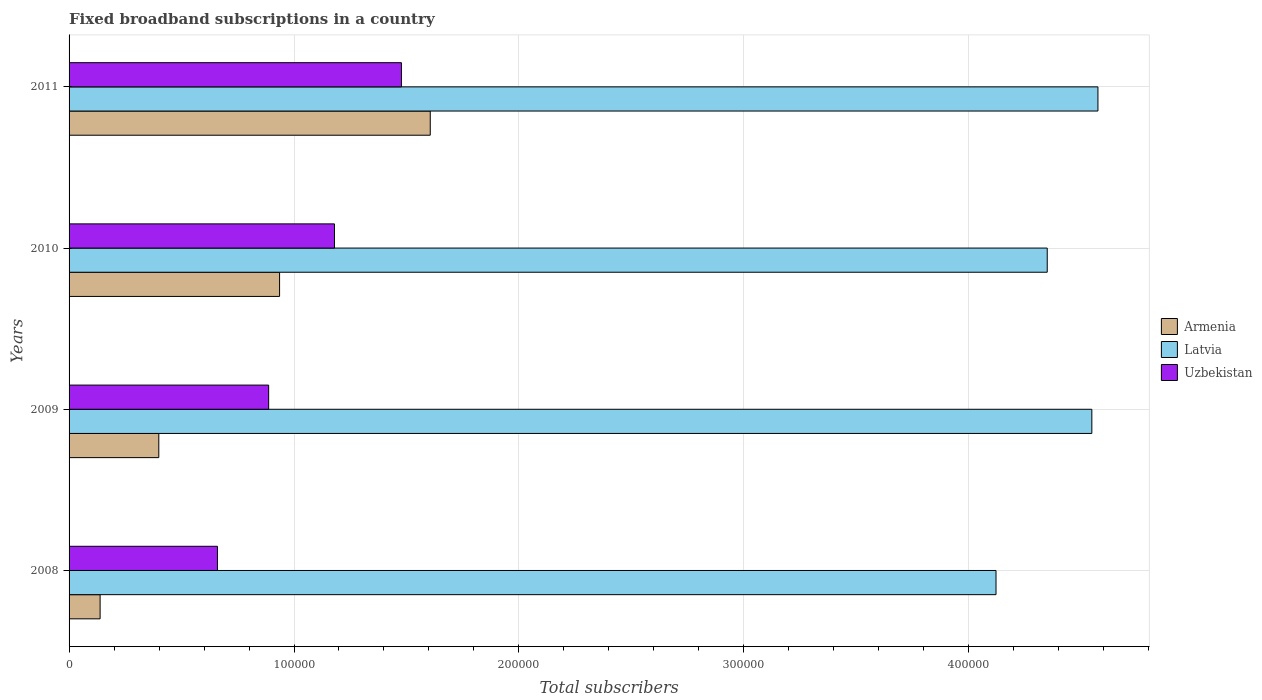Are the number of bars on each tick of the Y-axis equal?
Your answer should be compact. Yes. How many bars are there on the 2nd tick from the top?
Make the answer very short. 3. How many bars are there on the 1st tick from the bottom?
Offer a terse response. 3. In how many cases, is the number of bars for a given year not equal to the number of legend labels?
Your answer should be very brief. 0. What is the number of broadband subscriptions in Latvia in 2010?
Provide a short and direct response. 4.35e+05. Across all years, what is the maximum number of broadband subscriptions in Uzbekistan?
Offer a very short reply. 1.48e+05. Across all years, what is the minimum number of broadband subscriptions in Uzbekistan?
Provide a succinct answer. 6.60e+04. In which year was the number of broadband subscriptions in Latvia maximum?
Ensure brevity in your answer.  2011. What is the total number of broadband subscriptions in Armenia in the graph?
Your response must be concise. 3.08e+05. What is the difference between the number of broadband subscriptions in Latvia in 2009 and that in 2010?
Make the answer very short. 1.98e+04. What is the difference between the number of broadband subscriptions in Latvia in 2010 and the number of broadband subscriptions in Uzbekistan in 2008?
Ensure brevity in your answer.  3.69e+05. What is the average number of broadband subscriptions in Latvia per year?
Your answer should be very brief. 4.40e+05. In the year 2009, what is the difference between the number of broadband subscriptions in Latvia and number of broadband subscriptions in Armenia?
Give a very brief answer. 4.15e+05. In how many years, is the number of broadband subscriptions in Armenia greater than 460000 ?
Offer a very short reply. 0. What is the ratio of the number of broadband subscriptions in Uzbekistan in 2009 to that in 2011?
Keep it short and to the point. 0.6. Is the difference between the number of broadband subscriptions in Latvia in 2009 and 2011 greater than the difference between the number of broadband subscriptions in Armenia in 2009 and 2011?
Keep it short and to the point. Yes. What is the difference between the highest and the second highest number of broadband subscriptions in Armenia?
Your answer should be compact. 6.70e+04. What is the difference between the highest and the lowest number of broadband subscriptions in Armenia?
Offer a terse response. 1.47e+05. In how many years, is the number of broadband subscriptions in Latvia greater than the average number of broadband subscriptions in Latvia taken over all years?
Provide a short and direct response. 2. Is the sum of the number of broadband subscriptions in Armenia in 2008 and 2009 greater than the maximum number of broadband subscriptions in Uzbekistan across all years?
Provide a succinct answer. No. What does the 3rd bar from the top in 2011 represents?
Ensure brevity in your answer.  Armenia. What does the 3rd bar from the bottom in 2010 represents?
Your answer should be compact. Uzbekistan. Are all the bars in the graph horizontal?
Your answer should be very brief. Yes. How many years are there in the graph?
Provide a succinct answer. 4. What is the title of the graph?
Keep it short and to the point. Fixed broadband subscriptions in a country. What is the label or title of the X-axis?
Your answer should be very brief. Total subscribers. What is the Total subscribers of Armenia in 2008?
Make the answer very short. 1.38e+04. What is the Total subscribers of Latvia in 2008?
Your answer should be compact. 4.12e+05. What is the Total subscribers of Uzbekistan in 2008?
Offer a very short reply. 6.60e+04. What is the Total subscribers of Armenia in 2009?
Provide a succinct answer. 3.99e+04. What is the Total subscribers in Latvia in 2009?
Provide a short and direct response. 4.55e+05. What is the Total subscribers in Uzbekistan in 2009?
Your response must be concise. 8.87e+04. What is the Total subscribers in Armenia in 2010?
Ensure brevity in your answer.  9.36e+04. What is the Total subscribers of Latvia in 2010?
Give a very brief answer. 4.35e+05. What is the Total subscribers of Uzbekistan in 2010?
Your response must be concise. 1.18e+05. What is the Total subscribers in Armenia in 2011?
Ensure brevity in your answer.  1.61e+05. What is the Total subscribers in Latvia in 2011?
Offer a very short reply. 4.57e+05. What is the Total subscribers of Uzbekistan in 2011?
Ensure brevity in your answer.  1.48e+05. Across all years, what is the maximum Total subscribers of Armenia?
Ensure brevity in your answer.  1.61e+05. Across all years, what is the maximum Total subscribers of Latvia?
Provide a short and direct response. 4.57e+05. Across all years, what is the maximum Total subscribers of Uzbekistan?
Your answer should be compact. 1.48e+05. Across all years, what is the minimum Total subscribers of Armenia?
Ensure brevity in your answer.  1.38e+04. Across all years, what is the minimum Total subscribers of Latvia?
Your response must be concise. 4.12e+05. Across all years, what is the minimum Total subscribers in Uzbekistan?
Keep it short and to the point. 6.60e+04. What is the total Total subscribers in Armenia in the graph?
Give a very brief answer. 3.08e+05. What is the total Total subscribers in Latvia in the graph?
Your answer should be compact. 1.76e+06. What is the total Total subscribers in Uzbekistan in the graph?
Give a very brief answer. 4.20e+05. What is the difference between the Total subscribers in Armenia in 2008 and that in 2009?
Offer a very short reply. -2.61e+04. What is the difference between the Total subscribers in Latvia in 2008 and that in 2009?
Provide a succinct answer. -4.26e+04. What is the difference between the Total subscribers in Uzbekistan in 2008 and that in 2009?
Keep it short and to the point. -2.28e+04. What is the difference between the Total subscribers in Armenia in 2008 and that in 2010?
Offer a very short reply. -7.98e+04. What is the difference between the Total subscribers in Latvia in 2008 and that in 2010?
Offer a terse response. -2.28e+04. What is the difference between the Total subscribers in Uzbekistan in 2008 and that in 2010?
Ensure brevity in your answer.  -5.20e+04. What is the difference between the Total subscribers of Armenia in 2008 and that in 2011?
Give a very brief answer. -1.47e+05. What is the difference between the Total subscribers of Latvia in 2008 and that in 2011?
Your answer should be compact. -4.53e+04. What is the difference between the Total subscribers of Uzbekistan in 2008 and that in 2011?
Your response must be concise. -8.18e+04. What is the difference between the Total subscribers of Armenia in 2009 and that in 2010?
Offer a terse response. -5.37e+04. What is the difference between the Total subscribers in Latvia in 2009 and that in 2010?
Offer a terse response. 1.98e+04. What is the difference between the Total subscribers in Uzbekistan in 2009 and that in 2010?
Offer a very short reply. -2.93e+04. What is the difference between the Total subscribers in Armenia in 2009 and that in 2011?
Provide a succinct answer. -1.21e+05. What is the difference between the Total subscribers in Latvia in 2009 and that in 2011?
Offer a very short reply. -2708. What is the difference between the Total subscribers of Uzbekistan in 2009 and that in 2011?
Your answer should be compact. -5.90e+04. What is the difference between the Total subscribers in Armenia in 2010 and that in 2011?
Your answer should be very brief. -6.70e+04. What is the difference between the Total subscribers of Latvia in 2010 and that in 2011?
Keep it short and to the point. -2.25e+04. What is the difference between the Total subscribers in Uzbekistan in 2010 and that in 2011?
Offer a very short reply. -2.98e+04. What is the difference between the Total subscribers in Armenia in 2008 and the Total subscribers in Latvia in 2009?
Your response must be concise. -4.41e+05. What is the difference between the Total subscribers of Armenia in 2008 and the Total subscribers of Uzbekistan in 2009?
Offer a terse response. -7.49e+04. What is the difference between the Total subscribers of Latvia in 2008 and the Total subscribers of Uzbekistan in 2009?
Offer a terse response. 3.23e+05. What is the difference between the Total subscribers of Armenia in 2008 and the Total subscribers of Latvia in 2010?
Ensure brevity in your answer.  -4.21e+05. What is the difference between the Total subscribers of Armenia in 2008 and the Total subscribers of Uzbekistan in 2010?
Your response must be concise. -1.04e+05. What is the difference between the Total subscribers of Latvia in 2008 and the Total subscribers of Uzbekistan in 2010?
Provide a short and direct response. 2.94e+05. What is the difference between the Total subscribers of Armenia in 2008 and the Total subscribers of Latvia in 2011?
Offer a terse response. -4.44e+05. What is the difference between the Total subscribers in Armenia in 2008 and the Total subscribers in Uzbekistan in 2011?
Your response must be concise. -1.34e+05. What is the difference between the Total subscribers in Latvia in 2008 and the Total subscribers in Uzbekistan in 2011?
Your answer should be compact. 2.64e+05. What is the difference between the Total subscribers of Armenia in 2009 and the Total subscribers of Latvia in 2010?
Provide a short and direct response. -3.95e+05. What is the difference between the Total subscribers in Armenia in 2009 and the Total subscribers in Uzbekistan in 2010?
Give a very brief answer. -7.81e+04. What is the difference between the Total subscribers in Latvia in 2009 and the Total subscribers in Uzbekistan in 2010?
Offer a very short reply. 3.37e+05. What is the difference between the Total subscribers in Armenia in 2009 and the Total subscribers in Latvia in 2011?
Offer a very short reply. -4.18e+05. What is the difference between the Total subscribers in Armenia in 2009 and the Total subscribers in Uzbekistan in 2011?
Offer a terse response. -1.08e+05. What is the difference between the Total subscribers in Latvia in 2009 and the Total subscribers in Uzbekistan in 2011?
Provide a short and direct response. 3.07e+05. What is the difference between the Total subscribers in Armenia in 2010 and the Total subscribers in Latvia in 2011?
Make the answer very short. -3.64e+05. What is the difference between the Total subscribers of Armenia in 2010 and the Total subscribers of Uzbekistan in 2011?
Make the answer very short. -5.42e+04. What is the difference between the Total subscribers of Latvia in 2010 and the Total subscribers of Uzbekistan in 2011?
Keep it short and to the point. 2.87e+05. What is the average Total subscribers of Armenia per year?
Provide a short and direct response. 7.70e+04. What is the average Total subscribers in Latvia per year?
Keep it short and to the point. 4.40e+05. What is the average Total subscribers in Uzbekistan per year?
Give a very brief answer. 1.05e+05. In the year 2008, what is the difference between the Total subscribers in Armenia and Total subscribers in Latvia?
Your response must be concise. -3.98e+05. In the year 2008, what is the difference between the Total subscribers of Armenia and Total subscribers of Uzbekistan?
Offer a terse response. -5.22e+04. In the year 2008, what is the difference between the Total subscribers in Latvia and Total subscribers in Uzbekistan?
Your answer should be compact. 3.46e+05. In the year 2009, what is the difference between the Total subscribers of Armenia and Total subscribers of Latvia?
Your response must be concise. -4.15e+05. In the year 2009, what is the difference between the Total subscribers of Armenia and Total subscribers of Uzbekistan?
Offer a terse response. -4.88e+04. In the year 2009, what is the difference between the Total subscribers in Latvia and Total subscribers in Uzbekistan?
Offer a very short reply. 3.66e+05. In the year 2010, what is the difference between the Total subscribers of Armenia and Total subscribers of Latvia?
Offer a very short reply. -3.41e+05. In the year 2010, what is the difference between the Total subscribers in Armenia and Total subscribers in Uzbekistan?
Your response must be concise. -2.44e+04. In the year 2010, what is the difference between the Total subscribers in Latvia and Total subscribers in Uzbekistan?
Provide a succinct answer. 3.17e+05. In the year 2011, what is the difference between the Total subscribers of Armenia and Total subscribers of Latvia?
Your answer should be very brief. -2.97e+05. In the year 2011, what is the difference between the Total subscribers of Armenia and Total subscribers of Uzbekistan?
Your response must be concise. 1.28e+04. In the year 2011, what is the difference between the Total subscribers of Latvia and Total subscribers of Uzbekistan?
Offer a terse response. 3.10e+05. What is the ratio of the Total subscribers in Armenia in 2008 to that in 2009?
Keep it short and to the point. 0.35. What is the ratio of the Total subscribers of Latvia in 2008 to that in 2009?
Your answer should be compact. 0.91. What is the ratio of the Total subscribers of Uzbekistan in 2008 to that in 2009?
Ensure brevity in your answer.  0.74. What is the ratio of the Total subscribers in Armenia in 2008 to that in 2010?
Ensure brevity in your answer.  0.15. What is the ratio of the Total subscribers in Latvia in 2008 to that in 2010?
Offer a terse response. 0.95. What is the ratio of the Total subscribers of Uzbekistan in 2008 to that in 2010?
Your answer should be very brief. 0.56. What is the ratio of the Total subscribers of Armenia in 2008 to that in 2011?
Offer a terse response. 0.09. What is the ratio of the Total subscribers of Latvia in 2008 to that in 2011?
Give a very brief answer. 0.9. What is the ratio of the Total subscribers in Uzbekistan in 2008 to that in 2011?
Provide a short and direct response. 0.45. What is the ratio of the Total subscribers of Armenia in 2009 to that in 2010?
Offer a terse response. 0.43. What is the ratio of the Total subscribers in Latvia in 2009 to that in 2010?
Your response must be concise. 1.05. What is the ratio of the Total subscribers in Uzbekistan in 2009 to that in 2010?
Your answer should be very brief. 0.75. What is the ratio of the Total subscribers of Armenia in 2009 to that in 2011?
Ensure brevity in your answer.  0.25. What is the ratio of the Total subscribers in Uzbekistan in 2009 to that in 2011?
Give a very brief answer. 0.6. What is the ratio of the Total subscribers in Armenia in 2010 to that in 2011?
Provide a succinct answer. 0.58. What is the ratio of the Total subscribers in Latvia in 2010 to that in 2011?
Make the answer very short. 0.95. What is the ratio of the Total subscribers of Uzbekistan in 2010 to that in 2011?
Offer a terse response. 0.8. What is the difference between the highest and the second highest Total subscribers in Armenia?
Offer a terse response. 6.70e+04. What is the difference between the highest and the second highest Total subscribers in Latvia?
Offer a very short reply. 2708. What is the difference between the highest and the second highest Total subscribers of Uzbekistan?
Offer a terse response. 2.98e+04. What is the difference between the highest and the lowest Total subscribers in Armenia?
Make the answer very short. 1.47e+05. What is the difference between the highest and the lowest Total subscribers of Latvia?
Offer a very short reply. 4.53e+04. What is the difference between the highest and the lowest Total subscribers of Uzbekistan?
Give a very brief answer. 8.18e+04. 